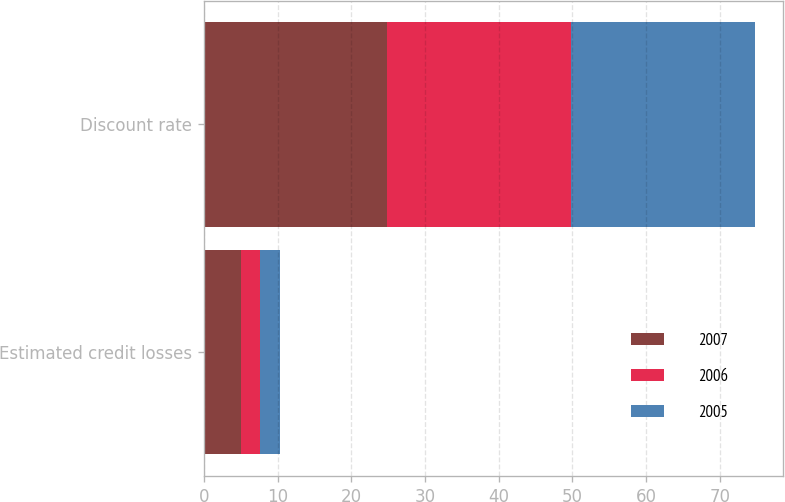Convert chart. <chart><loc_0><loc_0><loc_500><loc_500><stacked_bar_chart><ecel><fcel>Estimated credit losses<fcel>Discount rate<nl><fcel>2007<fcel>5.09<fcel>24.79<nl><fcel>2006<fcel>2.55<fcel>25<nl><fcel>2005<fcel>2.72<fcel>25<nl></chart> 